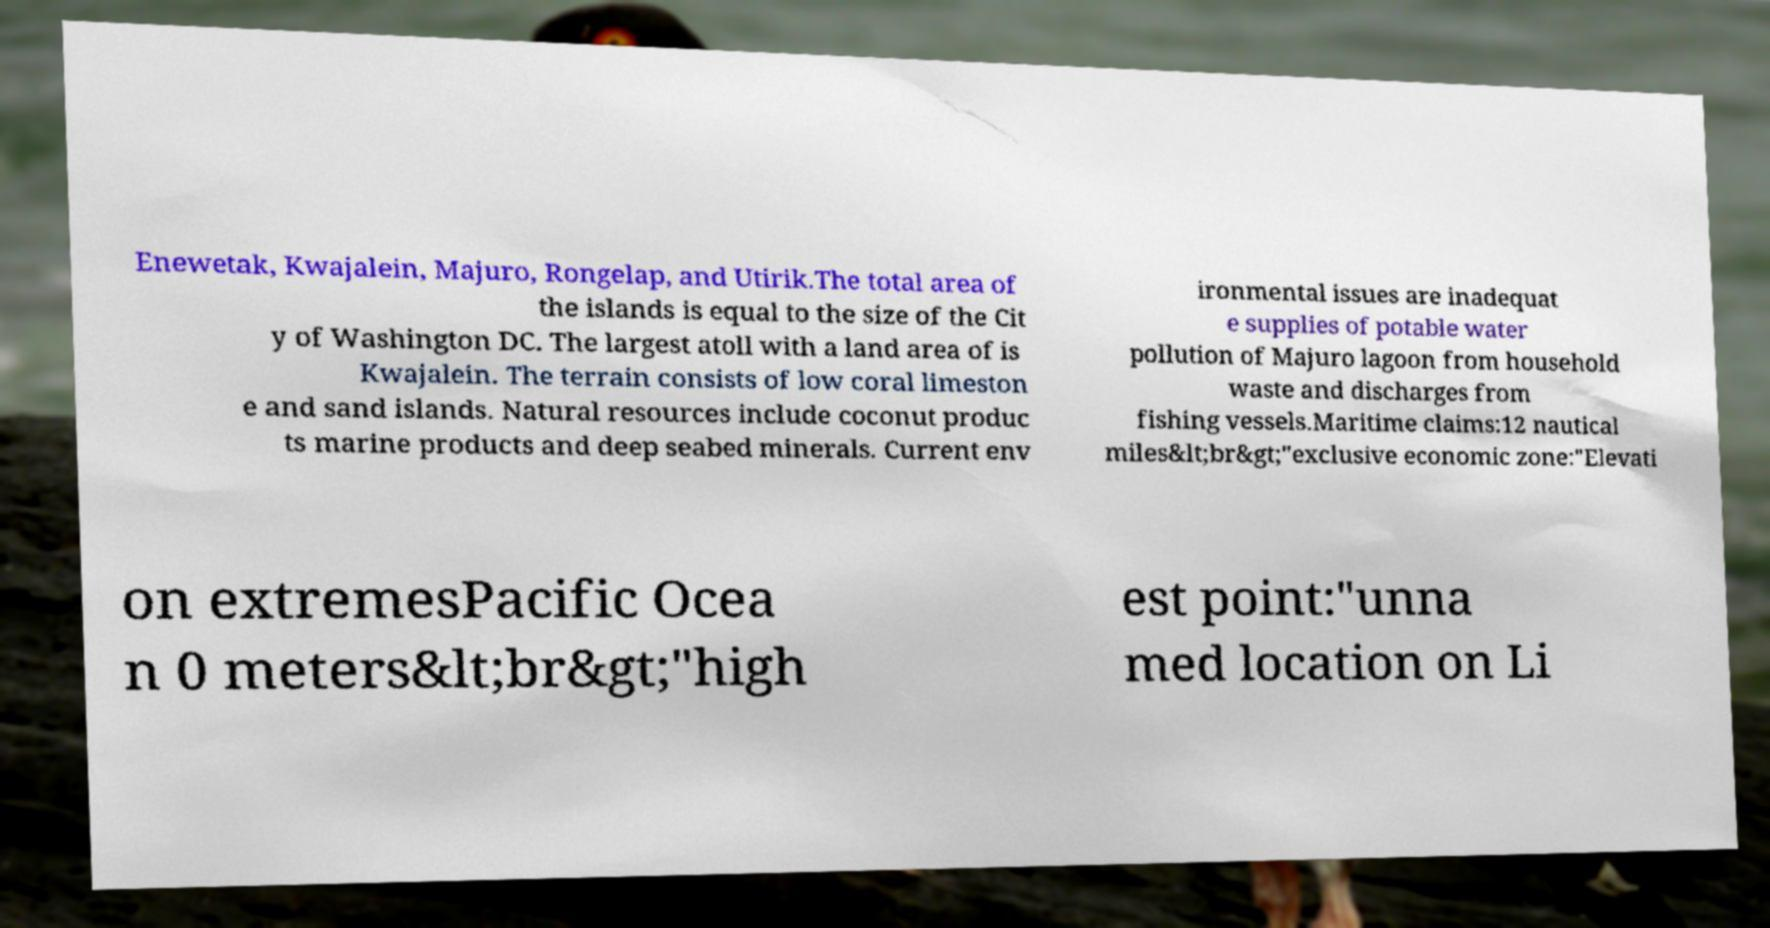For documentation purposes, I need the text within this image transcribed. Could you provide that? Enewetak, Kwajalein, Majuro, Rongelap, and Utirik.The total area of the islands is equal to the size of the Cit y of Washington DC. The largest atoll with a land area of is Kwajalein. The terrain consists of low coral limeston e and sand islands. Natural resources include coconut produc ts marine products and deep seabed minerals. Current env ironmental issues are inadequat e supplies of potable water pollution of Majuro lagoon from household waste and discharges from fishing vessels.Maritime claims:12 nautical miles&lt;br&gt;"exclusive economic zone:"Elevati on extremesPacific Ocea n 0 meters&lt;br&gt;"high est point:"unna med location on Li 